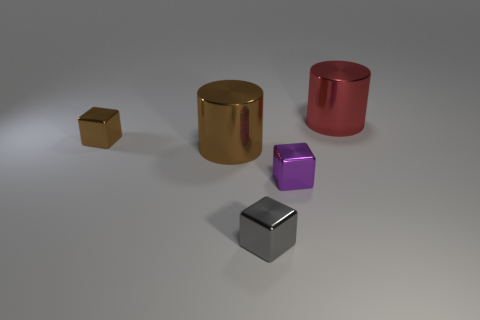Add 2 yellow rubber spheres. How many objects exist? 7 Subtract all blocks. How many objects are left? 2 Subtract 0 cyan spheres. How many objects are left? 5 Subtract all large purple metallic cylinders. Subtract all big objects. How many objects are left? 3 Add 2 gray metallic blocks. How many gray metallic blocks are left? 3 Add 1 tiny gray shiny cubes. How many tiny gray shiny cubes exist? 2 